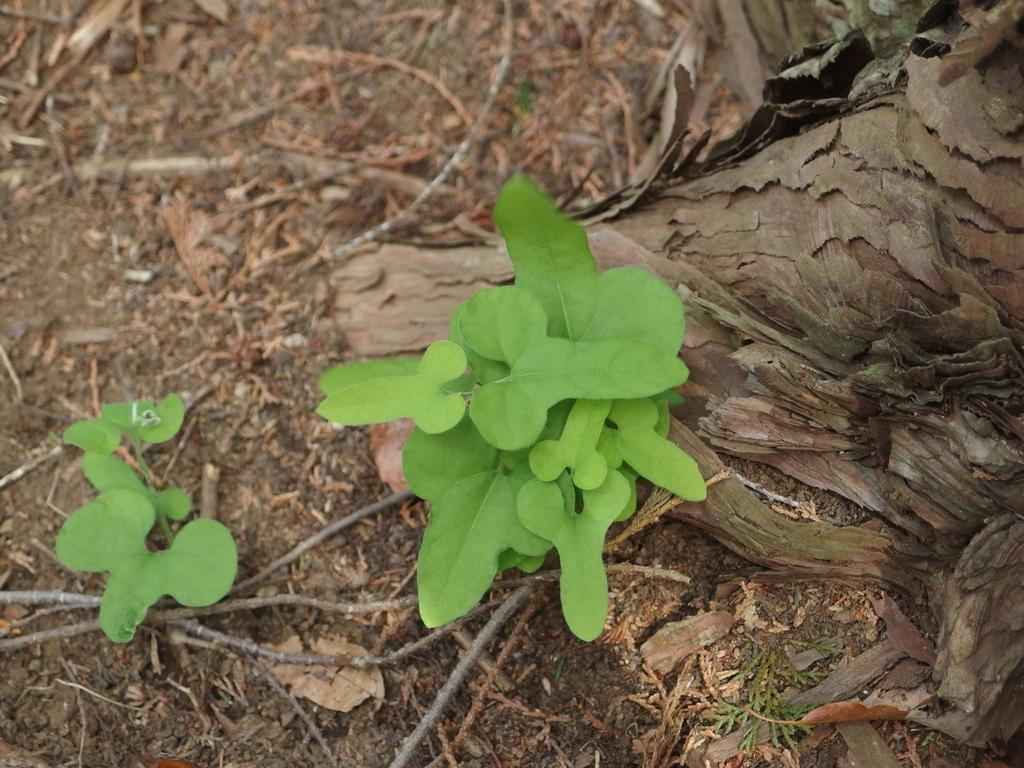How many plants are visible in the image? There are two small plants in the image. What can be seen around the plants? There are small dry sticks and dry leaves around the plants. What type of can is being used to water the plants in the image? There is no can present in the image, and the plants do not appear to be receiving water. 